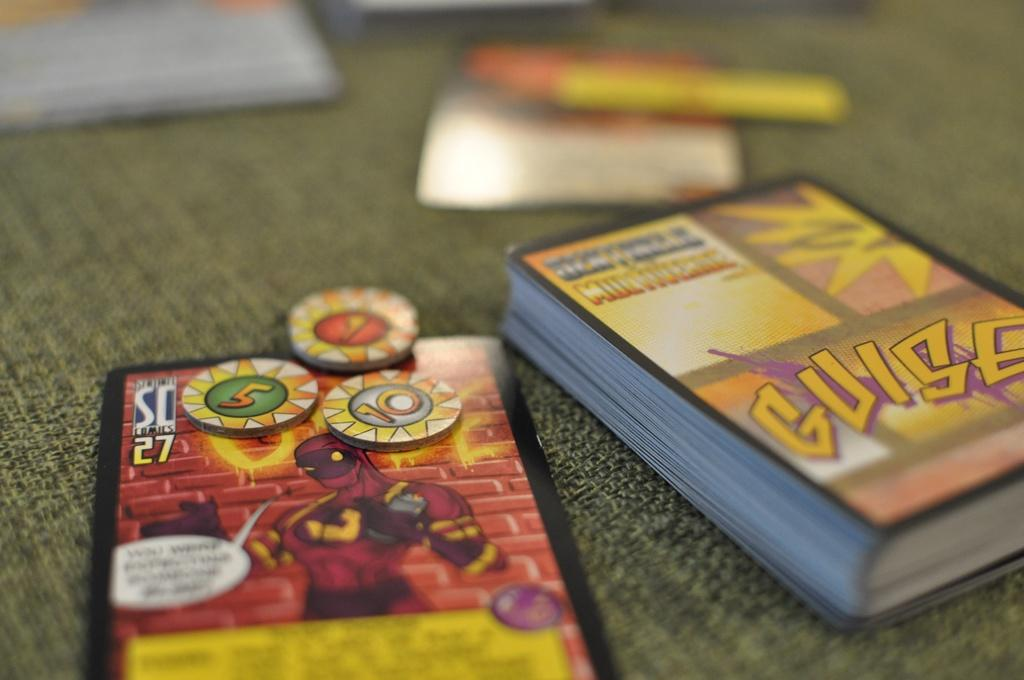<image>
Write a terse but informative summary of the picture. A stack of cards on a table with Guise on them with a card laying next to the stack. 